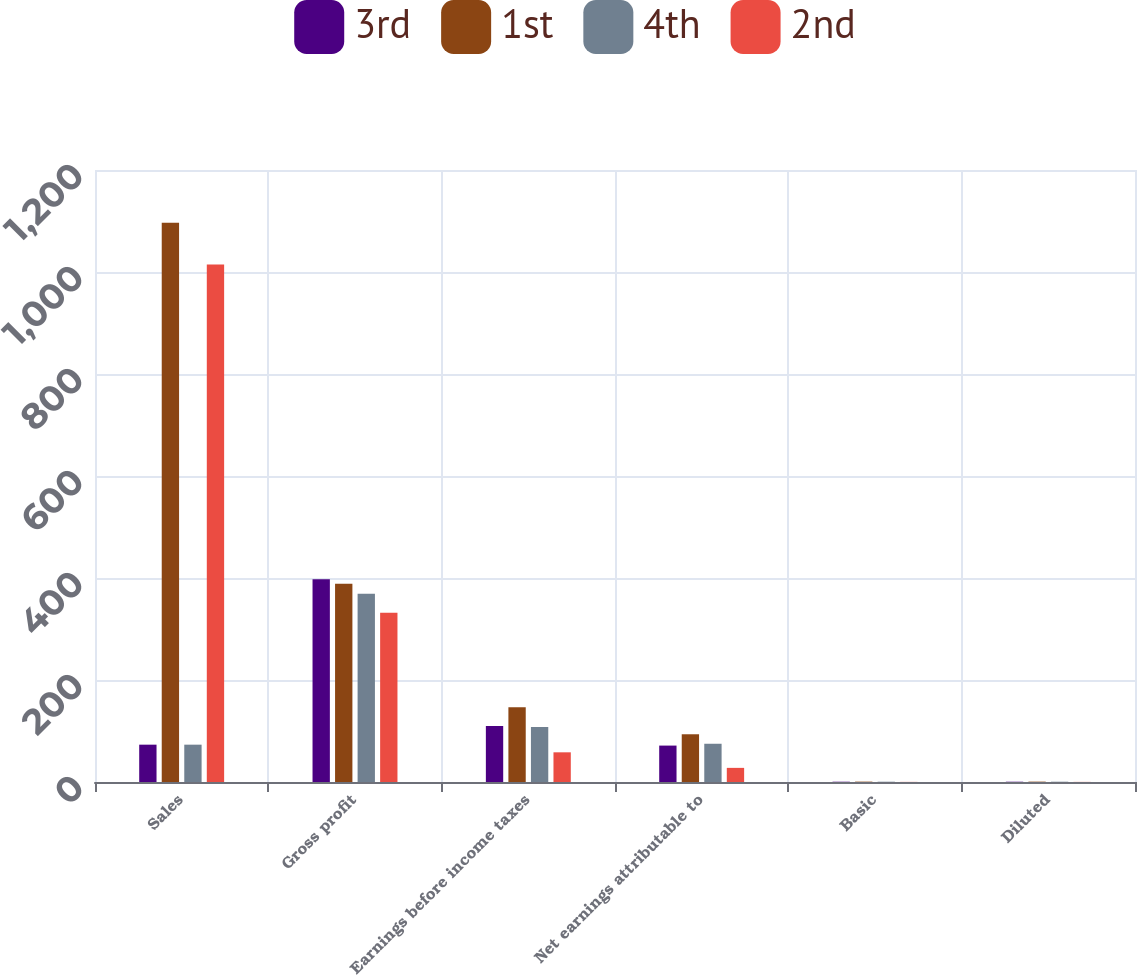Convert chart to OTSL. <chart><loc_0><loc_0><loc_500><loc_500><stacked_bar_chart><ecel><fcel>Sales<fcel>Gross profit<fcel>Earnings before income taxes<fcel>Net earnings attributable to<fcel>Basic<fcel>Diluted<nl><fcel>3rd<fcel>73.2<fcel>397.7<fcel>109.8<fcel>71.4<fcel>0.55<fcel>0.54<nl><fcel>1st<fcel>1096.5<fcel>388.8<fcel>146.6<fcel>93.6<fcel>0.71<fcel>0.7<nl><fcel>4th<fcel>73.2<fcel>369.1<fcel>107.6<fcel>75<fcel>0.56<fcel>0.56<nl><fcel>2nd<fcel>1014.6<fcel>331.7<fcel>58.2<fcel>27.7<fcel>0.21<fcel>0.2<nl></chart> 